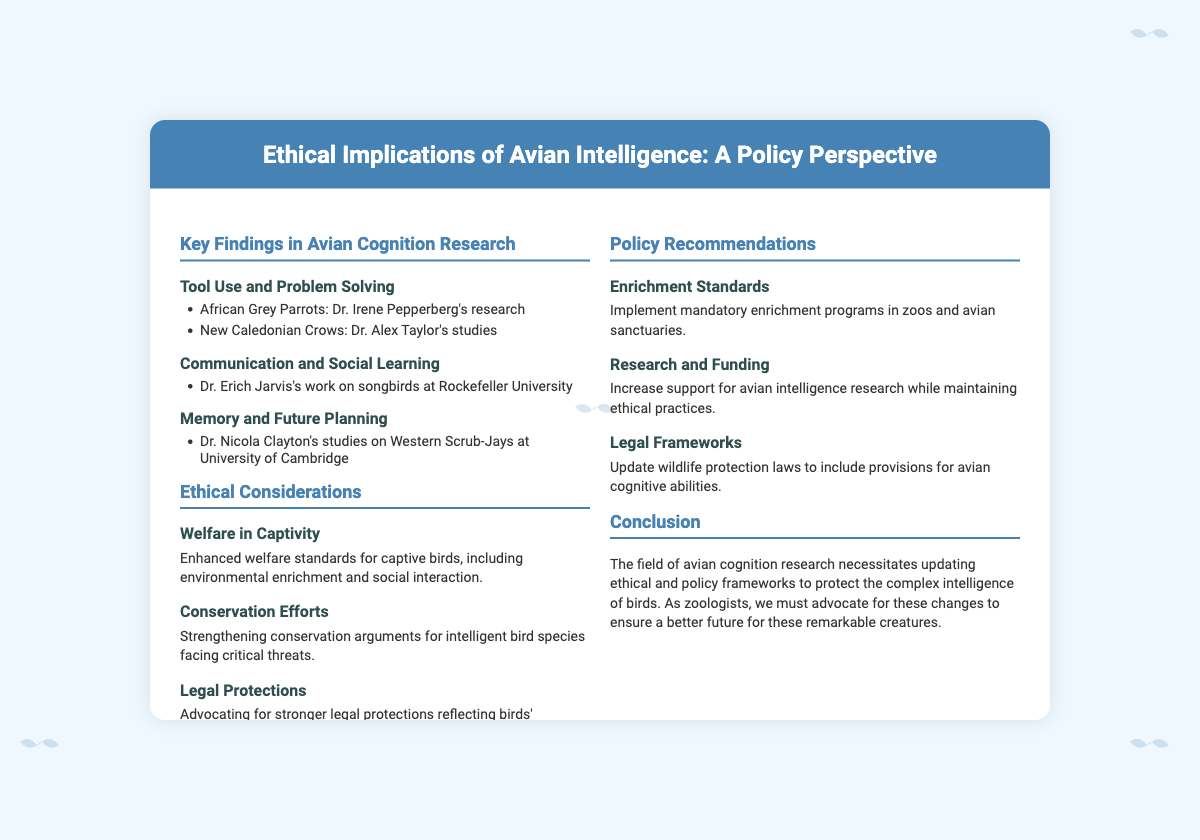What are the main subjects of avian cognition research mentioned? The document lists three main subjects of avian cognition research: Tool Use and Problem Solving, Communication and Social Learning, and Memory and Future Planning.
Answer: Tool Use and Problem Solving, Communication and Social Learning, Memory and Future Planning Who conducted research on African Grey Parrots? The document attributes research on African Grey Parrots to Dr. Irene Pepperberg.
Answer: Dr. Irene Pepperberg What is a key ethical consideration for birds in captivity? The document mentions that enhanced welfare standards for captive birds is a key ethical consideration.
Answer: Enhanced welfare standards for captive birds What should be updated according to the Policy Recommendations? The document recommends updating wildlife protection laws to include provisions for avian cognitive abilities.
Answer: Wildlife protection laws What type of birds does Dr. Nicola Clayton study? The document states that Dr. Nicola Clayton studies Western Scrub-Jays.
Answer: Western Scrub-Jays How many sections are in the left column of the slide? The left column has three sections: Key Findings in Avian Cognition Research, Ethical Considerations, and a conclusion.
Answer: Three What is the main conclusion of the presentation? The conclusion advises that ethical and policy frameworks should be updated to protect the intelligence of birds.
Answer: Update ethical and policy frameworks What specific recommendation is made concerning research support? The document suggests increasing support for avian intelligence research while maintaining ethical practices.
Answer: Increase support for avian intelligence research 